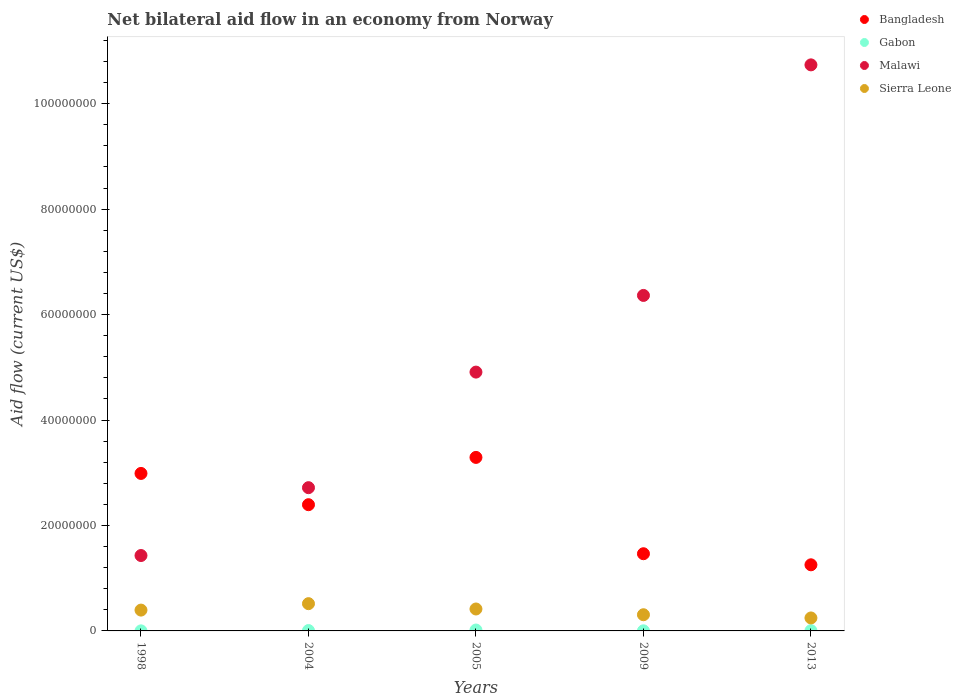Is the number of dotlines equal to the number of legend labels?
Your answer should be compact. Yes. What is the net bilateral aid flow in Sierra Leone in 2005?
Make the answer very short. 4.16e+06. Across all years, what is the maximum net bilateral aid flow in Gabon?
Provide a short and direct response. 1.70e+05. Across all years, what is the minimum net bilateral aid flow in Bangladesh?
Give a very brief answer. 1.25e+07. In which year was the net bilateral aid flow in Sierra Leone maximum?
Ensure brevity in your answer.  2004. In which year was the net bilateral aid flow in Gabon minimum?
Give a very brief answer. 1998. What is the total net bilateral aid flow in Gabon in the graph?
Offer a terse response. 3.20e+05. What is the difference between the net bilateral aid flow in Sierra Leone in 2005 and that in 2013?
Your response must be concise. 1.70e+06. What is the difference between the net bilateral aid flow in Gabon in 1998 and the net bilateral aid flow in Malawi in 2005?
Give a very brief answer. -4.91e+07. What is the average net bilateral aid flow in Gabon per year?
Keep it short and to the point. 6.40e+04. In the year 2009, what is the difference between the net bilateral aid flow in Bangladesh and net bilateral aid flow in Sierra Leone?
Your answer should be compact. 1.16e+07. In how many years, is the net bilateral aid flow in Sierra Leone greater than 60000000 US$?
Provide a succinct answer. 0. What is the ratio of the net bilateral aid flow in Malawi in 1998 to that in 2005?
Give a very brief answer. 0.29. Is the net bilateral aid flow in Malawi in 1998 less than that in 2004?
Your answer should be compact. Yes. Is the difference between the net bilateral aid flow in Bangladesh in 2004 and 2005 greater than the difference between the net bilateral aid flow in Sierra Leone in 2004 and 2005?
Make the answer very short. No. What is the difference between the highest and the second highest net bilateral aid flow in Sierra Leone?
Provide a succinct answer. 1.01e+06. What is the difference between the highest and the lowest net bilateral aid flow in Malawi?
Your answer should be very brief. 9.31e+07. In how many years, is the net bilateral aid flow in Bangladesh greater than the average net bilateral aid flow in Bangladesh taken over all years?
Offer a terse response. 3. Is the sum of the net bilateral aid flow in Sierra Leone in 1998 and 2009 greater than the maximum net bilateral aid flow in Bangladesh across all years?
Your answer should be very brief. No. Is it the case that in every year, the sum of the net bilateral aid flow in Sierra Leone and net bilateral aid flow in Gabon  is greater than the sum of net bilateral aid flow in Malawi and net bilateral aid flow in Bangladesh?
Make the answer very short. No. Is it the case that in every year, the sum of the net bilateral aid flow in Malawi and net bilateral aid flow in Bangladesh  is greater than the net bilateral aid flow in Gabon?
Your response must be concise. Yes. Is the net bilateral aid flow in Gabon strictly greater than the net bilateral aid flow in Bangladesh over the years?
Provide a succinct answer. No. How many dotlines are there?
Your response must be concise. 4. What is the difference between two consecutive major ticks on the Y-axis?
Your response must be concise. 2.00e+07. Where does the legend appear in the graph?
Give a very brief answer. Top right. How are the legend labels stacked?
Provide a short and direct response. Vertical. What is the title of the graph?
Your response must be concise. Net bilateral aid flow in an economy from Norway. What is the label or title of the Y-axis?
Provide a succinct answer. Aid flow (current US$). What is the Aid flow (current US$) in Bangladesh in 1998?
Provide a short and direct response. 2.99e+07. What is the Aid flow (current US$) of Malawi in 1998?
Your response must be concise. 1.43e+07. What is the Aid flow (current US$) of Sierra Leone in 1998?
Keep it short and to the point. 3.95e+06. What is the Aid flow (current US$) of Bangladesh in 2004?
Make the answer very short. 2.39e+07. What is the Aid flow (current US$) in Malawi in 2004?
Offer a terse response. 2.72e+07. What is the Aid flow (current US$) of Sierra Leone in 2004?
Make the answer very short. 5.17e+06. What is the Aid flow (current US$) of Bangladesh in 2005?
Give a very brief answer. 3.29e+07. What is the Aid flow (current US$) in Malawi in 2005?
Ensure brevity in your answer.  4.91e+07. What is the Aid flow (current US$) of Sierra Leone in 2005?
Offer a terse response. 4.16e+06. What is the Aid flow (current US$) of Bangladesh in 2009?
Your answer should be compact. 1.46e+07. What is the Aid flow (current US$) in Malawi in 2009?
Provide a succinct answer. 6.36e+07. What is the Aid flow (current US$) in Sierra Leone in 2009?
Keep it short and to the point. 3.07e+06. What is the Aid flow (current US$) in Bangladesh in 2013?
Ensure brevity in your answer.  1.25e+07. What is the Aid flow (current US$) in Malawi in 2013?
Your answer should be compact. 1.07e+08. What is the Aid flow (current US$) in Sierra Leone in 2013?
Make the answer very short. 2.46e+06. Across all years, what is the maximum Aid flow (current US$) in Bangladesh?
Your response must be concise. 3.29e+07. Across all years, what is the maximum Aid flow (current US$) in Gabon?
Give a very brief answer. 1.70e+05. Across all years, what is the maximum Aid flow (current US$) in Malawi?
Make the answer very short. 1.07e+08. Across all years, what is the maximum Aid flow (current US$) of Sierra Leone?
Your answer should be compact. 5.17e+06. Across all years, what is the minimum Aid flow (current US$) of Bangladesh?
Make the answer very short. 1.25e+07. Across all years, what is the minimum Aid flow (current US$) of Gabon?
Your answer should be compact. 10000. Across all years, what is the minimum Aid flow (current US$) in Malawi?
Your response must be concise. 1.43e+07. Across all years, what is the minimum Aid flow (current US$) in Sierra Leone?
Offer a terse response. 2.46e+06. What is the total Aid flow (current US$) of Bangladesh in the graph?
Offer a terse response. 1.14e+08. What is the total Aid flow (current US$) of Malawi in the graph?
Offer a very short reply. 2.62e+08. What is the total Aid flow (current US$) in Sierra Leone in the graph?
Provide a succinct answer. 1.88e+07. What is the difference between the Aid flow (current US$) of Bangladesh in 1998 and that in 2004?
Offer a terse response. 5.93e+06. What is the difference between the Aid flow (current US$) of Malawi in 1998 and that in 2004?
Your answer should be very brief. -1.29e+07. What is the difference between the Aid flow (current US$) in Sierra Leone in 1998 and that in 2004?
Give a very brief answer. -1.22e+06. What is the difference between the Aid flow (current US$) in Bangladesh in 1998 and that in 2005?
Provide a succinct answer. -3.04e+06. What is the difference between the Aid flow (current US$) of Malawi in 1998 and that in 2005?
Provide a succinct answer. -3.48e+07. What is the difference between the Aid flow (current US$) in Sierra Leone in 1998 and that in 2005?
Keep it short and to the point. -2.10e+05. What is the difference between the Aid flow (current US$) in Bangladesh in 1998 and that in 2009?
Keep it short and to the point. 1.52e+07. What is the difference between the Aid flow (current US$) of Malawi in 1998 and that in 2009?
Ensure brevity in your answer.  -4.93e+07. What is the difference between the Aid flow (current US$) of Sierra Leone in 1998 and that in 2009?
Offer a very short reply. 8.80e+05. What is the difference between the Aid flow (current US$) of Bangladesh in 1998 and that in 2013?
Offer a very short reply. 1.73e+07. What is the difference between the Aid flow (current US$) in Gabon in 1998 and that in 2013?
Offer a very short reply. -4.00e+04. What is the difference between the Aid flow (current US$) in Malawi in 1998 and that in 2013?
Provide a short and direct response. -9.31e+07. What is the difference between the Aid flow (current US$) of Sierra Leone in 1998 and that in 2013?
Your answer should be compact. 1.49e+06. What is the difference between the Aid flow (current US$) in Bangladesh in 2004 and that in 2005?
Your answer should be very brief. -8.97e+06. What is the difference between the Aid flow (current US$) in Malawi in 2004 and that in 2005?
Ensure brevity in your answer.  -2.19e+07. What is the difference between the Aid flow (current US$) of Sierra Leone in 2004 and that in 2005?
Ensure brevity in your answer.  1.01e+06. What is the difference between the Aid flow (current US$) in Bangladesh in 2004 and that in 2009?
Your answer should be very brief. 9.30e+06. What is the difference between the Aid flow (current US$) in Malawi in 2004 and that in 2009?
Your answer should be very brief. -3.65e+07. What is the difference between the Aid flow (current US$) of Sierra Leone in 2004 and that in 2009?
Offer a very short reply. 2.10e+06. What is the difference between the Aid flow (current US$) in Bangladesh in 2004 and that in 2013?
Make the answer very short. 1.14e+07. What is the difference between the Aid flow (current US$) in Malawi in 2004 and that in 2013?
Make the answer very short. -8.02e+07. What is the difference between the Aid flow (current US$) in Sierra Leone in 2004 and that in 2013?
Your answer should be very brief. 2.71e+06. What is the difference between the Aid flow (current US$) in Bangladesh in 2005 and that in 2009?
Keep it short and to the point. 1.83e+07. What is the difference between the Aid flow (current US$) of Malawi in 2005 and that in 2009?
Your response must be concise. -1.45e+07. What is the difference between the Aid flow (current US$) of Sierra Leone in 2005 and that in 2009?
Your response must be concise. 1.09e+06. What is the difference between the Aid flow (current US$) of Bangladesh in 2005 and that in 2013?
Your answer should be compact. 2.04e+07. What is the difference between the Aid flow (current US$) in Malawi in 2005 and that in 2013?
Ensure brevity in your answer.  -5.83e+07. What is the difference between the Aid flow (current US$) of Sierra Leone in 2005 and that in 2013?
Provide a short and direct response. 1.70e+06. What is the difference between the Aid flow (current US$) in Bangladesh in 2009 and that in 2013?
Your response must be concise. 2.10e+06. What is the difference between the Aid flow (current US$) in Gabon in 2009 and that in 2013?
Keep it short and to the point. -3.00e+04. What is the difference between the Aid flow (current US$) of Malawi in 2009 and that in 2013?
Your answer should be very brief. -4.37e+07. What is the difference between the Aid flow (current US$) of Bangladesh in 1998 and the Aid flow (current US$) of Gabon in 2004?
Your response must be concise. 2.98e+07. What is the difference between the Aid flow (current US$) in Bangladesh in 1998 and the Aid flow (current US$) in Malawi in 2004?
Give a very brief answer. 2.70e+06. What is the difference between the Aid flow (current US$) of Bangladesh in 1998 and the Aid flow (current US$) of Sierra Leone in 2004?
Offer a very short reply. 2.47e+07. What is the difference between the Aid flow (current US$) of Gabon in 1998 and the Aid flow (current US$) of Malawi in 2004?
Keep it short and to the point. -2.72e+07. What is the difference between the Aid flow (current US$) in Gabon in 1998 and the Aid flow (current US$) in Sierra Leone in 2004?
Give a very brief answer. -5.16e+06. What is the difference between the Aid flow (current US$) in Malawi in 1998 and the Aid flow (current US$) in Sierra Leone in 2004?
Keep it short and to the point. 9.13e+06. What is the difference between the Aid flow (current US$) in Bangladesh in 1998 and the Aid flow (current US$) in Gabon in 2005?
Provide a short and direct response. 2.97e+07. What is the difference between the Aid flow (current US$) in Bangladesh in 1998 and the Aid flow (current US$) in Malawi in 2005?
Ensure brevity in your answer.  -1.92e+07. What is the difference between the Aid flow (current US$) of Bangladesh in 1998 and the Aid flow (current US$) of Sierra Leone in 2005?
Provide a short and direct response. 2.57e+07. What is the difference between the Aid flow (current US$) of Gabon in 1998 and the Aid flow (current US$) of Malawi in 2005?
Offer a terse response. -4.91e+07. What is the difference between the Aid flow (current US$) of Gabon in 1998 and the Aid flow (current US$) of Sierra Leone in 2005?
Make the answer very short. -4.15e+06. What is the difference between the Aid flow (current US$) of Malawi in 1998 and the Aid flow (current US$) of Sierra Leone in 2005?
Your response must be concise. 1.01e+07. What is the difference between the Aid flow (current US$) in Bangladesh in 1998 and the Aid flow (current US$) in Gabon in 2009?
Make the answer very short. 2.98e+07. What is the difference between the Aid flow (current US$) in Bangladesh in 1998 and the Aid flow (current US$) in Malawi in 2009?
Provide a short and direct response. -3.38e+07. What is the difference between the Aid flow (current US$) of Bangladesh in 1998 and the Aid flow (current US$) of Sierra Leone in 2009?
Provide a short and direct response. 2.68e+07. What is the difference between the Aid flow (current US$) in Gabon in 1998 and the Aid flow (current US$) in Malawi in 2009?
Give a very brief answer. -6.36e+07. What is the difference between the Aid flow (current US$) of Gabon in 1998 and the Aid flow (current US$) of Sierra Leone in 2009?
Your answer should be compact. -3.06e+06. What is the difference between the Aid flow (current US$) of Malawi in 1998 and the Aid flow (current US$) of Sierra Leone in 2009?
Offer a very short reply. 1.12e+07. What is the difference between the Aid flow (current US$) in Bangladesh in 1998 and the Aid flow (current US$) in Gabon in 2013?
Your answer should be very brief. 2.98e+07. What is the difference between the Aid flow (current US$) in Bangladesh in 1998 and the Aid flow (current US$) in Malawi in 2013?
Offer a terse response. -7.75e+07. What is the difference between the Aid flow (current US$) of Bangladesh in 1998 and the Aid flow (current US$) of Sierra Leone in 2013?
Your response must be concise. 2.74e+07. What is the difference between the Aid flow (current US$) in Gabon in 1998 and the Aid flow (current US$) in Malawi in 2013?
Provide a succinct answer. -1.07e+08. What is the difference between the Aid flow (current US$) of Gabon in 1998 and the Aid flow (current US$) of Sierra Leone in 2013?
Make the answer very short. -2.45e+06. What is the difference between the Aid flow (current US$) of Malawi in 1998 and the Aid flow (current US$) of Sierra Leone in 2013?
Keep it short and to the point. 1.18e+07. What is the difference between the Aid flow (current US$) in Bangladesh in 2004 and the Aid flow (current US$) in Gabon in 2005?
Offer a very short reply. 2.38e+07. What is the difference between the Aid flow (current US$) of Bangladesh in 2004 and the Aid flow (current US$) of Malawi in 2005?
Provide a succinct answer. -2.52e+07. What is the difference between the Aid flow (current US$) in Bangladesh in 2004 and the Aid flow (current US$) in Sierra Leone in 2005?
Your answer should be compact. 1.98e+07. What is the difference between the Aid flow (current US$) in Gabon in 2004 and the Aid flow (current US$) in Malawi in 2005?
Your answer should be compact. -4.90e+07. What is the difference between the Aid flow (current US$) of Gabon in 2004 and the Aid flow (current US$) of Sierra Leone in 2005?
Your answer should be very brief. -4.09e+06. What is the difference between the Aid flow (current US$) in Malawi in 2004 and the Aid flow (current US$) in Sierra Leone in 2005?
Make the answer very short. 2.30e+07. What is the difference between the Aid flow (current US$) in Bangladesh in 2004 and the Aid flow (current US$) in Gabon in 2009?
Provide a succinct answer. 2.39e+07. What is the difference between the Aid flow (current US$) of Bangladesh in 2004 and the Aid flow (current US$) of Malawi in 2009?
Your response must be concise. -3.97e+07. What is the difference between the Aid flow (current US$) of Bangladesh in 2004 and the Aid flow (current US$) of Sierra Leone in 2009?
Offer a terse response. 2.09e+07. What is the difference between the Aid flow (current US$) of Gabon in 2004 and the Aid flow (current US$) of Malawi in 2009?
Give a very brief answer. -6.36e+07. What is the difference between the Aid flow (current US$) in Gabon in 2004 and the Aid flow (current US$) in Sierra Leone in 2009?
Provide a short and direct response. -3.00e+06. What is the difference between the Aid flow (current US$) in Malawi in 2004 and the Aid flow (current US$) in Sierra Leone in 2009?
Make the answer very short. 2.41e+07. What is the difference between the Aid flow (current US$) in Bangladesh in 2004 and the Aid flow (current US$) in Gabon in 2013?
Provide a succinct answer. 2.39e+07. What is the difference between the Aid flow (current US$) in Bangladesh in 2004 and the Aid flow (current US$) in Malawi in 2013?
Your response must be concise. -8.34e+07. What is the difference between the Aid flow (current US$) in Bangladesh in 2004 and the Aid flow (current US$) in Sierra Leone in 2013?
Your response must be concise. 2.15e+07. What is the difference between the Aid flow (current US$) of Gabon in 2004 and the Aid flow (current US$) of Malawi in 2013?
Make the answer very short. -1.07e+08. What is the difference between the Aid flow (current US$) of Gabon in 2004 and the Aid flow (current US$) of Sierra Leone in 2013?
Offer a terse response. -2.39e+06. What is the difference between the Aid flow (current US$) of Malawi in 2004 and the Aid flow (current US$) of Sierra Leone in 2013?
Ensure brevity in your answer.  2.47e+07. What is the difference between the Aid flow (current US$) of Bangladesh in 2005 and the Aid flow (current US$) of Gabon in 2009?
Your response must be concise. 3.29e+07. What is the difference between the Aid flow (current US$) in Bangladesh in 2005 and the Aid flow (current US$) in Malawi in 2009?
Offer a terse response. -3.07e+07. What is the difference between the Aid flow (current US$) of Bangladesh in 2005 and the Aid flow (current US$) of Sierra Leone in 2009?
Give a very brief answer. 2.98e+07. What is the difference between the Aid flow (current US$) in Gabon in 2005 and the Aid flow (current US$) in Malawi in 2009?
Your answer should be very brief. -6.35e+07. What is the difference between the Aid flow (current US$) of Gabon in 2005 and the Aid flow (current US$) of Sierra Leone in 2009?
Offer a very short reply. -2.90e+06. What is the difference between the Aid flow (current US$) in Malawi in 2005 and the Aid flow (current US$) in Sierra Leone in 2009?
Your answer should be compact. 4.60e+07. What is the difference between the Aid flow (current US$) of Bangladesh in 2005 and the Aid flow (current US$) of Gabon in 2013?
Offer a very short reply. 3.29e+07. What is the difference between the Aid flow (current US$) of Bangladesh in 2005 and the Aid flow (current US$) of Malawi in 2013?
Your response must be concise. -7.44e+07. What is the difference between the Aid flow (current US$) of Bangladesh in 2005 and the Aid flow (current US$) of Sierra Leone in 2013?
Provide a short and direct response. 3.04e+07. What is the difference between the Aid flow (current US$) of Gabon in 2005 and the Aid flow (current US$) of Malawi in 2013?
Provide a short and direct response. -1.07e+08. What is the difference between the Aid flow (current US$) in Gabon in 2005 and the Aid flow (current US$) in Sierra Leone in 2013?
Your answer should be compact. -2.29e+06. What is the difference between the Aid flow (current US$) in Malawi in 2005 and the Aid flow (current US$) in Sierra Leone in 2013?
Your response must be concise. 4.66e+07. What is the difference between the Aid flow (current US$) in Bangladesh in 2009 and the Aid flow (current US$) in Gabon in 2013?
Keep it short and to the point. 1.46e+07. What is the difference between the Aid flow (current US$) of Bangladesh in 2009 and the Aid flow (current US$) of Malawi in 2013?
Keep it short and to the point. -9.27e+07. What is the difference between the Aid flow (current US$) in Bangladesh in 2009 and the Aid flow (current US$) in Sierra Leone in 2013?
Your response must be concise. 1.22e+07. What is the difference between the Aid flow (current US$) in Gabon in 2009 and the Aid flow (current US$) in Malawi in 2013?
Offer a terse response. -1.07e+08. What is the difference between the Aid flow (current US$) in Gabon in 2009 and the Aid flow (current US$) in Sierra Leone in 2013?
Provide a short and direct response. -2.44e+06. What is the difference between the Aid flow (current US$) of Malawi in 2009 and the Aid flow (current US$) of Sierra Leone in 2013?
Give a very brief answer. 6.12e+07. What is the average Aid flow (current US$) in Bangladesh per year?
Your response must be concise. 2.28e+07. What is the average Aid flow (current US$) in Gabon per year?
Keep it short and to the point. 6.40e+04. What is the average Aid flow (current US$) in Malawi per year?
Provide a succinct answer. 5.23e+07. What is the average Aid flow (current US$) of Sierra Leone per year?
Provide a short and direct response. 3.76e+06. In the year 1998, what is the difference between the Aid flow (current US$) of Bangladesh and Aid flow (current US$) of Gabon?
Your response must be concise. 2.99e+07. In the year 1998, what is the difference between the Aid flow (current US$) in Bangladesh and Aid flow (current US$) in Malawi?
Keep it short and to the point. 1.56e+07. In the year 1998, what is the difference between the Aid flow (current US$) in Bangladesh and Aid flow (current US$) in Sierra Leone?
Offer a terse response. 2.59e+07. In the year 1998, what is the difference between the Aid flow (current US$) of Gabon and Aid flow (current US$) of Malawi?
Give a very brief answer. -1.43e+07. In the year 1998, what is the difference between the Aid flow (current US$) in Gabon and Aid flow (current US$) in Sierra Leone?
Ensure brevity in your answer.  -3.94e+06. In the year 1998, what is the difference between the Aid flow (current US$) in Malawi and Aid flow (current US$) in Sierra Leone?
Ensure brevity in your answer.  1.04e+07. In the year 2004, what is the difference between the Aid flow (current US$) in Bangladesh and Aid flow (current US$) in Gabon?
Make the answer very short. 2.39e+07. In the year 2004, what is the difference between the Aid flow (current US$) in Bangladesh and Aid flow (current US$) in Malawi?
Provide a short and direct response. -3.23e+06. In the year 2004, what is the difference between the Aid flow (current US$) in Bangladesh and Aid flow (current US$) in Sierra Leone?
Keep it short and to the point. 1.88e+07. In the year 2004, what is the difference between the Aid flow (current US$) in Gabon and Aid flow (current US$) in Malawi?
Ensure brevity in your answer.  -2.71e+07. In the year 2004, what is the difference between the Aid flow (current US$) in Gabon and Aid flow (current US$) in Sierra Leone?
Provide a succinct answer. -5.10e+06. In the year 2004, what is the difference between the Aid flow (current US$) of Malawi and Aid flow (current US$) of Sierra Leone?
Offer a terse response. 2.20e+07. In the year 2005, what is the difference between the Aid flow (current US$) in Bangladesh and Aid flow (current US$) in Gabon?
Keep it short and to the point. 3.27e+07. In the year 2005, what is the difference between the Aid flow (current US$) in Bangladesh and Aid flow (current US$) in Malawi?
Your response must be concise. -1.62e+07. In the year 2005, what is the difference between the Aid flow (current US$) of Bangladesh and Aid flow (current US$) of Sierra Leone?
Make the answer very short. 2.88e+07. In the year 2005, what is the difference between the Aid flow (current US$) of Gabon and Aid flow (current US$) of Malawi?
Provide a succinct answer. -4.89e+07. In the year 2005, what is the difference between the Aid flow (current US$) in Gabon and Aid flow (current US$) in Sierra Leone?
Ensure brevity in your answer.  -3.99e+06. In the year 2005, what is the difference between the Aid flow (current US$) in Malawi and Aid flow (current US$) in Sierra Leone?
Ensure brevity in your answer.  4.49e+07. In the year 2009, what is the difference between the Aid flow (current US$) in Bangladesh and Aid flow (current US$) in Gabon?
Keep it short and to the point. 1.46e+07. In the year 2009, what is the difference between the Aid flow (current US$) in Bangladesh and Aid flow (current US$) in Malawi?
Make the answer very short. -4.90e+07. In the year 2009, what is the difference between the Aid flow (current US$) in Bangladesh and Aid flow (current US$) in Sierra Leone?
Your answer should be compact. 1.16e+07. In the year 2009, what is the difference between the Aid flow (current US$) of Gabon and Aid flow (current US$) of Malawi?
Offer a terse response. -6.36e+07. In the year 2009, what is the difference between the Aid flow (current US$) in Gabon and Aid flow (current US$) in Sierra Leone?
Ensure brevity in your answer.  -3.05e+06. In the year 2009, what is the difference between the Aid flow (current US$) of Malawi and Aid flow (current US$) of Sierra Leone?
Offer a terse response. 6.06e+07. In the year 2013, what is the difference between the Aid flow (current US$) of Bangladesh and Aid flow (current US$) of Gabon?
Your response must be concise. 1.25e+07. In the year 2013, what is the difference between the Aid flow (current US$) of Bangladesh and Aid flow (current US$) of Malawi?
Your answer should be very brief. -9.48e+07. In the year 2013, what is the difference between the Aid flow (current US$) of Bangladesh and Aid flow (current US$) of Sierra Leone?
Your response must be concise. 1.01e+07. In the year 2013, what is the difference between the Aid flow (current US$) in Gabon and Aid flow (current US$) in Malawi?
Your answer should be compact. -1.07e+08. In the year 2013, what is the difference between the Aid flow (current US$) in Gabon and Aid flow (current US$) in Sierra Leone?
Give a very brief answer. -2.41e+06. In the year 2013, what is the difference between the Aid flow (current US$) in Malawi and Aid flow (current US$) in Sierra Leone?
Make the answer very short. 1.05e+08. What is the ratio of the Aid flow (current US$) of Bangladesh in 1998 to that in 2004?
Offer a very short reply. 1.25. What is the ratio of the Aid flow (current US$) of Gabon in 1998 to that in 2004?
Make the answer very short. 0.14. What is the ratio of the Aid flow (current US$) of Malawi in 1998 to that in 2004?
Provide a short and direct response. 0.53. What is the ratio of the Aid flow (current US$) of Sierra Leone in 1998 to that in 2004?
Offer a very short reply. 0.76. What is the ratio of the Aid flow (current US$) of Bangladesh in 1998 to that in 2005?
Give a very brief answer. 0.91. What is the ratio of the Aid flow (current US$) of Gabon in 1998 to that in 2005?
Your answer should be very brief. 0.06. What is the ratio of the Aid flow (current US$) in Malawi in 1998 to that in 2005?
Keep it short and to the point. 0.29. What is the ratio of the Aid flow (current US$) of Sierra Leone in 1998 to that in 2005?
Ensure brevity in your answer.  0.95. What is the ratio of the Aid flow (current US$) in Bangladesh in 1998 to that in 2009?
Offer a terse response. 2.04. What is the ratio of the Aid flow (current US$) of Gabon in 1998 to that in 2009?
Make the answer very short. 0.5. What is the ratio of the Aid flow (current US$) in Malawi in 1998 to that in 2009?
Your answer should be very brief. 0.22. What is the ratio of the Aid flow (current US$) in Sierra Leone in 1998 to that in 2009?
Ensure brevity in your answer.  1.29. What is the ratio of the Aid flow (current US$) in Bangladesh in 1998 to that in 2013?
Provide a succinct answer. 2.38. What is the ratio of the Aid flow (current US$) of Gabon in 1998 to that in 2013?
Provide a succinct answer. 0.2. What is the ratio of the Aid flow (current US$) of Malawi in 1998 to that in 2013?
Ensure brevity in your answer.  0.13. What is the ratio of the Aid flow (current US$) of Sierra Leone in 1998 to that in 2013?
Your answer should be compact. 1.61. What is the ratio of the Aid flow (current US$) of Bangladesh in 2004 to that in 2005?
Your answer should be very brief. 0.73. What is the ratio of the Aid flow (current US$) of Gabon in 2004 to that in 2005?
Give a very brief answer. 0.41. What is the ratio of the Aid flow (current US$) of Malawi in 2004 to that in 2005?
Your response must be concise. 0.55. What is the ratio of the Aid flow (current US$) in Sierra Leone in 2004 to that in 2005?
Make the answer very short. 1.24. What is the ratio of the Aid flow (current US$) of Bangladesh in 2004 to that in 2009?
Provide a short and direct response. 1.64. What is the ratio of the Aid flow (current US$) in Gabon in 2004 to that in 2009?
Offer a very short reply. 3.5. What is the ratio of the Aid flow (current US$) in Malawi in 2004 to that in 2009?
Your answer should be compact. 0.43. What is the ratio of the Aid flow (current US$) in Sierra Leone in 2004 to that in 2009?
Keep it short and to the point. 1.68. What is the ratio of the Aid flow (current US$) in Bangladesh in 2004 to that in 2013?
Ensure brevity in your answer.  1.91. What is the ratio of the Aid flow (current US$) in Malawi in 2004 to that in 2013?
Offer a very short reply. 0.25. What is the ratio of the Aid flow (current US$) of Sierra Leone in 2004 to that in 2013?
Keep it short and to the point. 2.1. What is the ratio of the Aid flow (current US$) of Bangladesh in 2005 to that in 2009?
Make the answer very short. 2.25. What is the ratio of the Aid flow (current US$) in Gabon in 2005 to that in 2009?
Give a very brief answer. 8.5. What is the ratio of the Aid flow (current US$) of Malawi in 2005 to that in 2009?
Give a very brief answer. 0.77. What is the ratio of the Aid flow (current US$) in Sierra Leone in 2005 to that in 2009?
Make the answer very short. 1.35. What is the ratio of the Aid flow (current US$) of Bangladesh in 2005 to that in 2013?
Your response must be concise. 2.62. What is the ratio of the Aid flow (current US$) of Gabon in 2005 to that in 2013?
Make the answer very short. 3.4. What is the ratio of the Aid flow (current US$) of Malawi in 2005 to that in 2013?
Provide a short and direct response. 0.46. What is the ratio of the Aid flow (current US$) of Sierra Leone in 2005 to that in 2013?
Provide a short and direct response. 1.69. What is the ratio of the Aid flow (current US$) in Bangladesh in 2009 to that in 2013?
Give a very brief answer. 1.17. What is the ratio of the Aid flow (current US$) in Gabon in 2009 to that in 2013?
Make the answer very short. 0.4. What is the ratio of the Aid flow (current US$) in Malawi in 2009 to that in 2013?
Provide a succinct answer. 0.59. What is the ratio of the Aid flow (current US$) in Sierra Leone in 2009 to that in 2013?
Your response must be concise. 1.25. What is the difference between the highest and the second highest Aid flow (current US$) in Bangladesh?
Keep it short and to the point. 3.04e+06. What is the difference between the highest and the second highest Aid flow (current US$) in Gabon?
Ensure brevity in your answer.  1.00e+05. What is the difference between the highest and the second highest Aid flow (current US$) of Malawi?
Offer a very short reply. 4.37e+07. What is the difference between the highest and the second highest Aid flow (current US$) of Sierra Leone?
Offer a terse response. 1.01e+06. What is the difference between the highest and the lowest Aid flow (current US$) of Bangladesh?
Your answer should be compact. 2.04e+07. What is the difference between the highest and the lowest Aid flow (current US$) of Malawi?
Make the answer very short. 9.31e+07. What is the difference between the highest and the lowest Aid flow (current US$) in Sierra Leone?
Provide a succinct answer. 2.71e+06. 